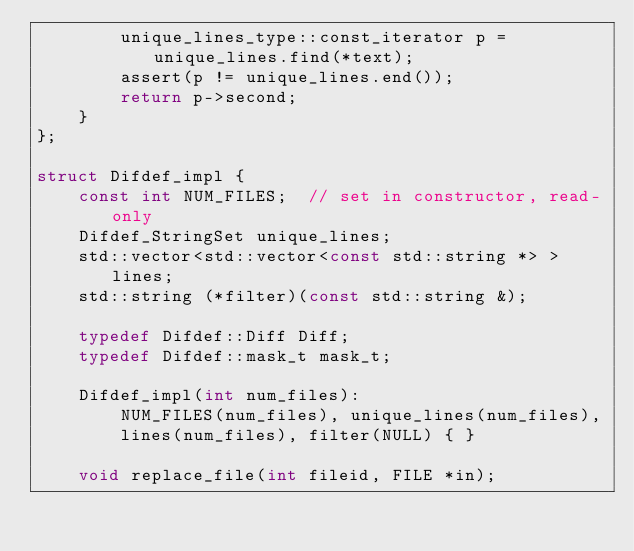<code> <loc_0><loc_0><loc_500><loc_500><_C_>        unique_lines_type::const_iterator p = unique_lines.find(*text);
        assert(p != unique_lines.end());
        return p->second;
    }
};

struct Difdef_impl {
    const int NUM_FILES;  // set in constructor, read-only
    Difdef_StringSet unique_lines;
    std::vector<std::vector<const std::string *> > lines;
    std::string (*filter)(const std::string &);

    typedef Difdef::Diff Diff;
    typedef Difdef::mask_t mask_t;

    Difdef_impl(int num_files):
        NUM_FILES(num_files), unique_lines(num_files),
        lines(num_files), filter(NULL) { }

    void replace_file(int fileid, FILE *in);
</code> 